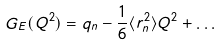<formula> <loc_0><loc_0><loc_500><loc_500>G _ { E } ( Q ^ { 2 } ) = q _ { n } - \frac { 1 } { 6 } \langle r _ { n } ^ { 2 } \rangle Q ^ { 2 } + \dots</formula> 